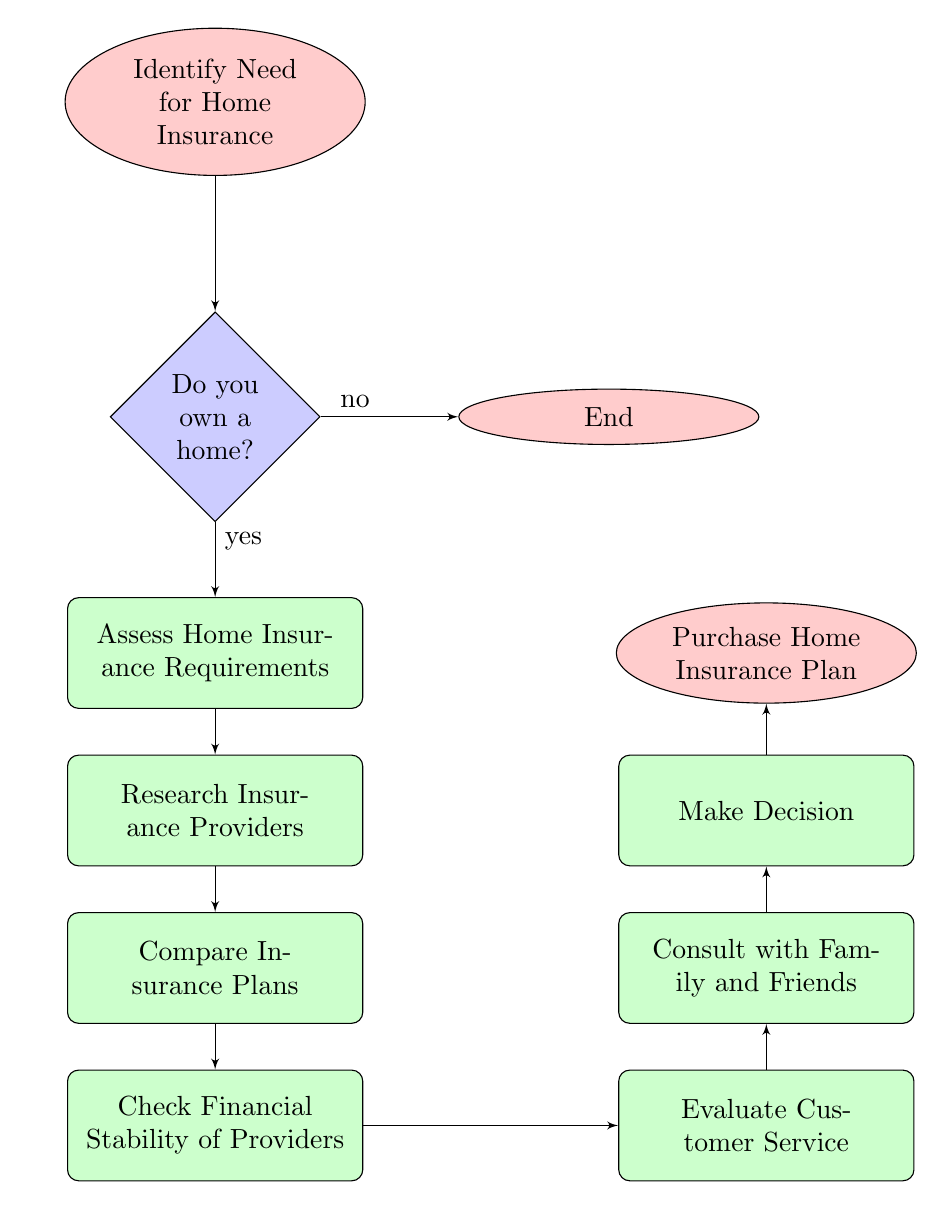What is the starting point of the flow chart? The starting point of the flow chart is labeled "Identify Need for Home Insurance," indicating that the process begins with recognizing the necessity for home insurance.
Answer: Identify Need for Home Insurance What happens if you do not own a home? According to the flow chart, if the response to the question "Do you own a home?" is "no," the process proceeds to the "End" node, meaning no further action is needed.
Answer: End How many main process nodes are there in the flow chart? The flow chart contains five main process nodes, which are: Assess Home Insurance Requirements, Research Insurance Providers, Compare Insurance Plans, Check Financial Stability of Providers, and Evaluate Customer Service.
Answer: Five What is the action taken after researching insurance providers? After completing the action of researching insurance providers, the next step indicated in the flow chart is to "Compare Insurance Plans." This signifies the transition to evaluating different insurance options.
Answer: Compare Insurance Plans What two things are checked in the "Check Financial Stability of Providers" process? In this process, financial stability is verified through ratings from agencies such as A.M. Best and Moody’s. This highlights the importance of considering the financial health of the insurance providers before making a selection.
Answer: A.M. Best, Moody’s What is consulted after evaluating customer service? The diagram indicates that "Consult with Family and Friends" is the subsequent step after evaluating customer service, emphasizing the importance of seeking advice from trusted sources before making a decision.
Answer: Consult with Family and Friends What should be the final action taken in the process? The final action in the process, as depicted in the flow chart, is to "Purchase Home Insurance Plan," signifying the completion of the decision-making journey for obtaining home insurance.
Answer: Purchase Home Insurance Plan 